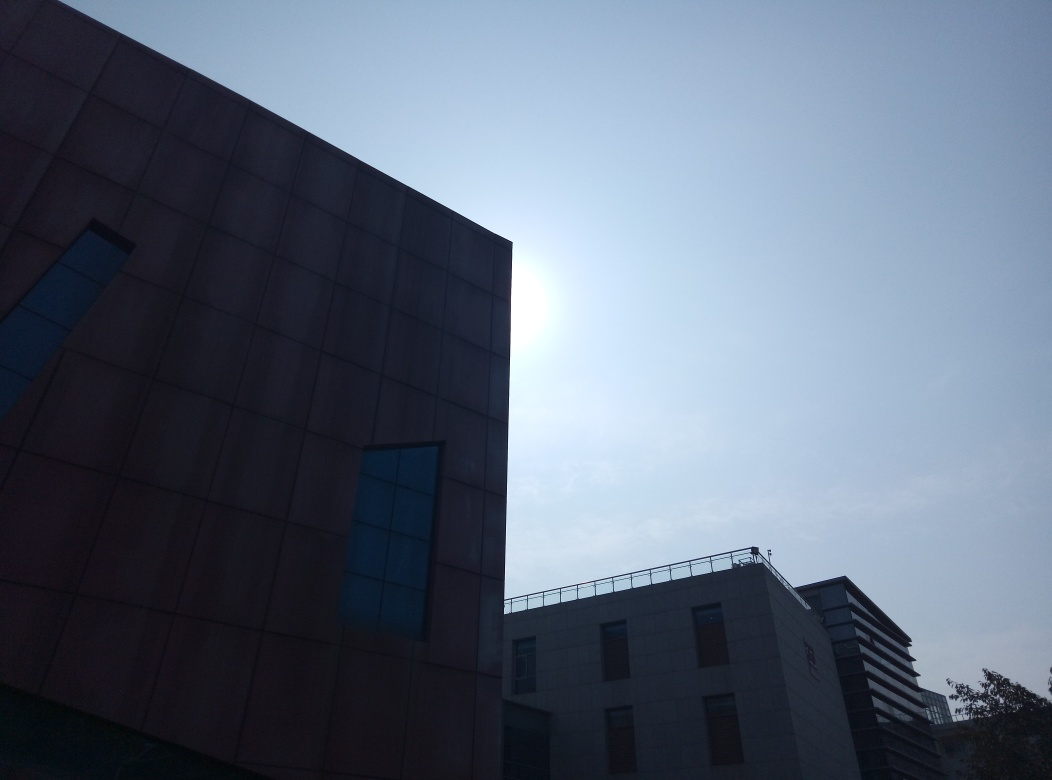How could the composition of this image be improved to better convey its architectural elements? Enhancing the composition to better showcase architectural details could involve cropping or repositioning to focus more directly on interesting elements like the contrast between the different building materials and geometries. Additionally, adjusting the angle to reduce the amount of sky can help focus the viewer’s attention more on the building itself, perhaps capturing it during different lighting conditions to reduce the silhouette effect and bring out more details. 